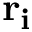<formula> <loc_0><loc_0><loc_500><loc_500>{ r _ { i } }</formula> 